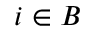Convert formula to latex. <formula><loc_0><loc_0><loc_500><loc_500>i \in B</formula> 